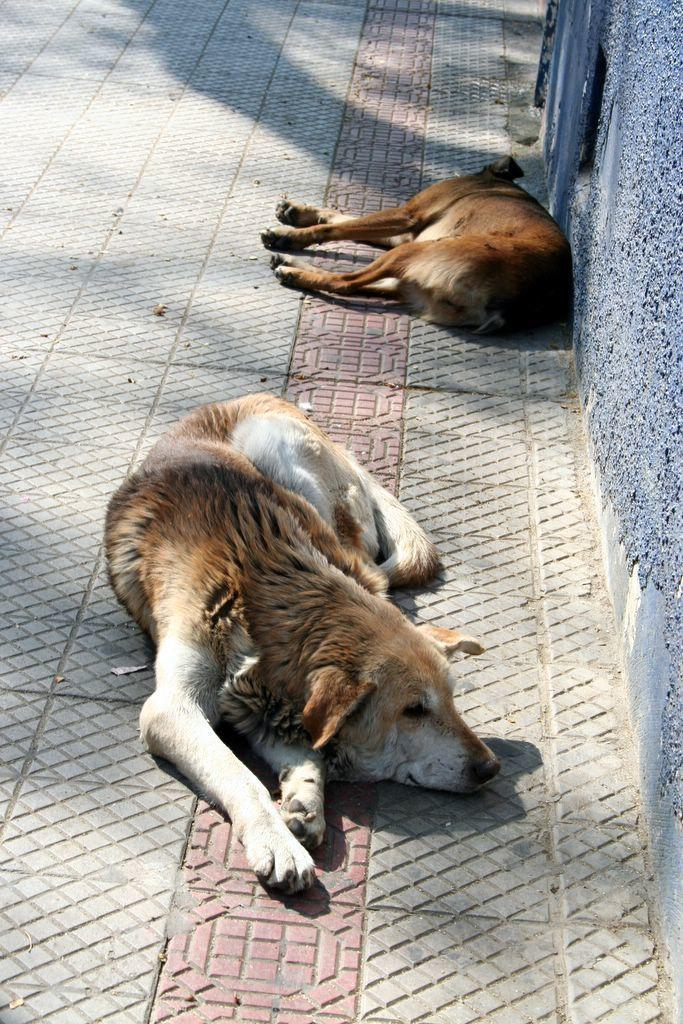What can be seen in the image that people might walk on? There is a path in the image that people might walk on. What animals are present on the path? Two dogs are sleeping on the path. What is located near the path? There is a wall near the path. What color is the wall? The wall is purple in color. What type of suit is the actor wearing while walking on the path? There is no actor or suit present in the image; it features a path with two sleeping dogs and a purple wall. 